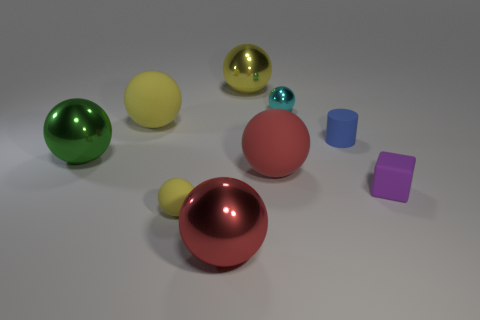Subtract all yellow spheres. How many were subtracted if there are1yellow spheres left? 2 Subtract all blue cubes. How many yellow spheres are left? 3 Subtract all large red metal spheres. How many spheres are left? 6 Subtract all green balls. How many balls are left? 6 Subtract all purple spheres. Subtract all blue blocks. How many spheres are left? 7 Add 1 tiny yellow rubber spheres. How many objects exist? 10 Subtract all spheres. How many objects are left? 2 Subtract all small cyan metal objects. Subtract all metallic things. How many objects are left? 4 Add 4 green metal spheres. How many green metal spheres are left? 5 Add 4 tiny brown matte spheres. How many tiny brown matte spheres exist? 4 